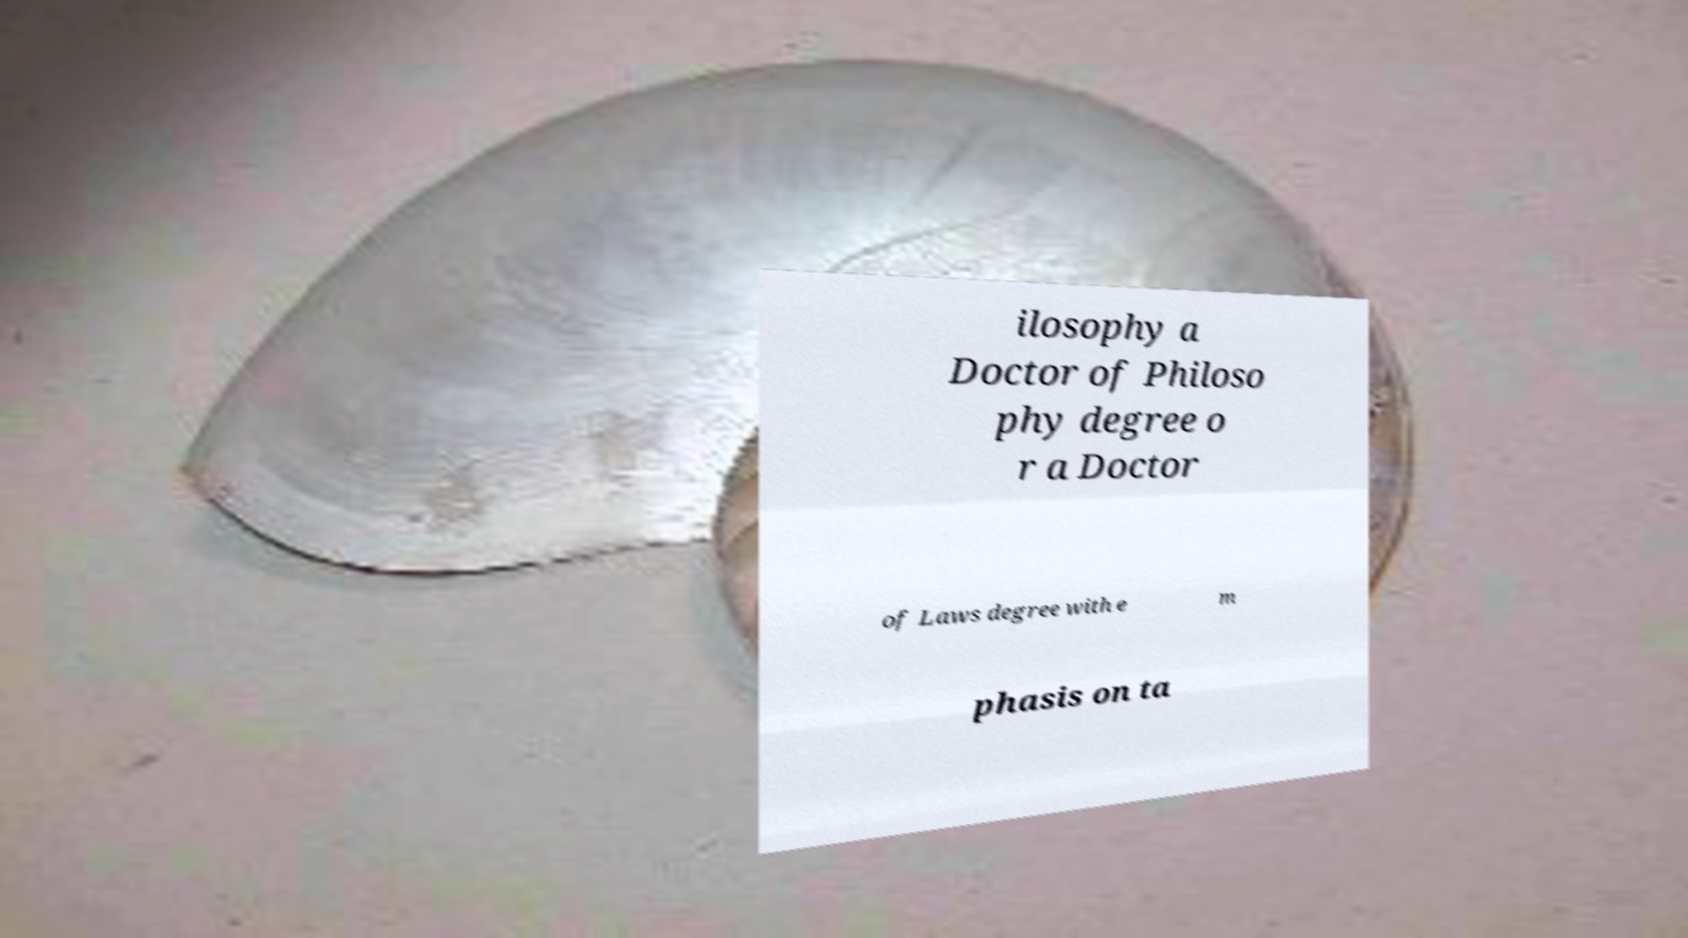Please identify and transcribe the text found in this image. ilosophy a Doctor of Philoso phy degree o r a Doctor of Laws degree with e m phasis on ta 